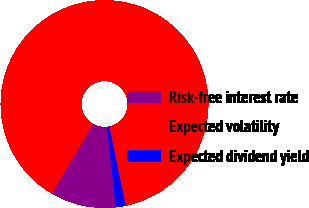Convert chart. <chart><loc_0><loc_0><loc_500><loc_500><pie_chart><fcel>Risk-free interest rate<fcel>Expected volatility<fcel>Expected dividend yield<nl><fcel>10.2%<fcel>88.28%<fcel>1.52%<nl></chart> 